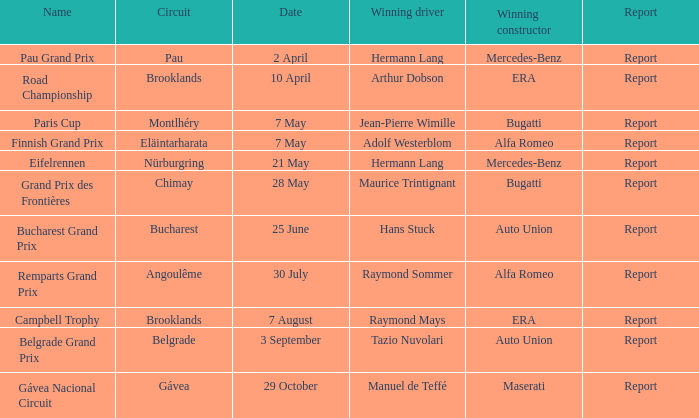Tell me the report for 10 april Report. 